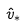Convert formula to latex. <formula><loc_0><loc_0><loc_500><loc_500>\hat { v } _ { * }</formula> 